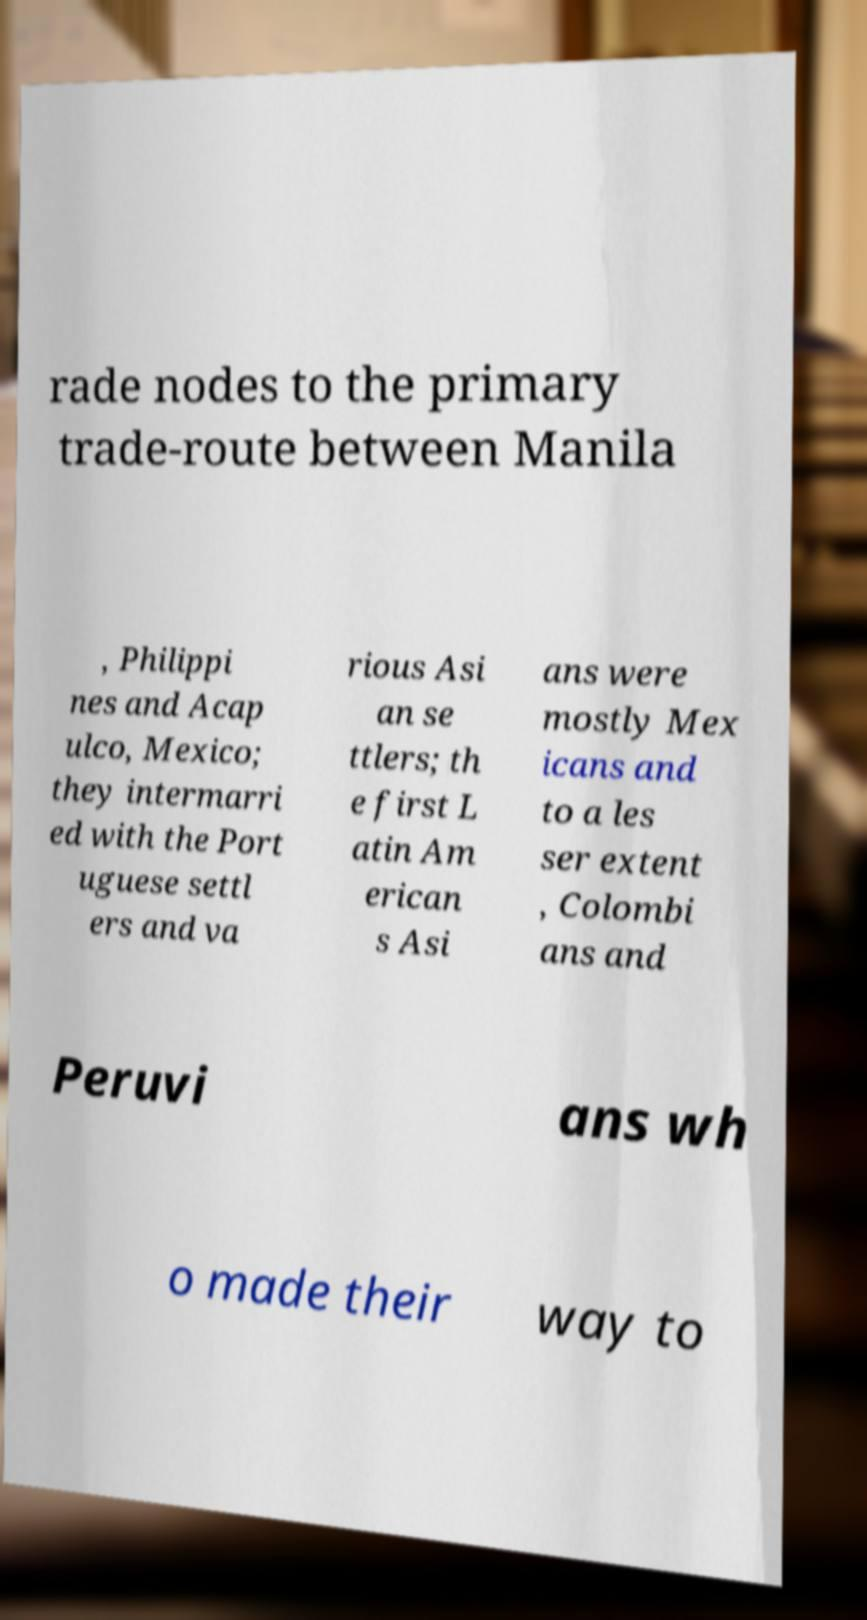I need the written content from this picture converted into text. Can you do that? rade nodes to the primary trade-route between Manila , Philippi nes and Acap ulco, Mexico; they intermarri ed with the Port uguese settl ers and va rious Asi an se ttlers; th e first L atin Am erican s Asi ans were mostly Mex icans and to a les ser extent , Colombi ans and Peruvi ans wh o made their way to 